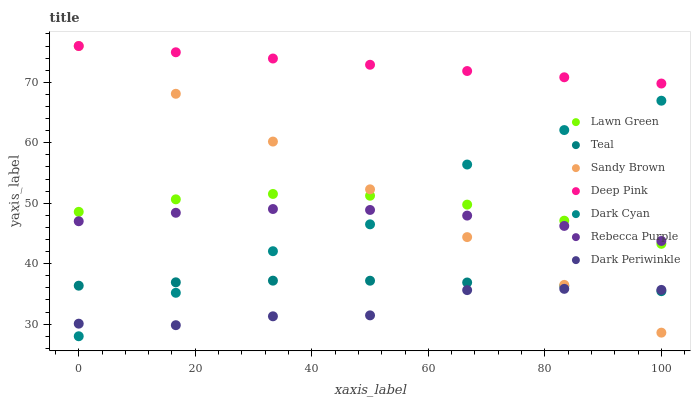Does Dark Periwinkle have the minimum area under the curve?
Answer yes or no. Yes. Does Deep Pink have the maximum area under the curve?
Answer yes or no. Yes. Does Rebecca Purple have the minimum area under the curve?
Answer yes or no. No. Does Rebecca Purple have the maximum area under the curve?
Answer yes or no. No. Is Sandy Brown the smoothest?
Answer yes or no. Yes. Is Dark Cyan the roughest?
Answer yes or no. Yes. Is Deep Pink the smoothest?
Answer yes or no. No. Is Deep Pink the roughest?
Answer yes or no. No. Does Dark Cyan have the lowest value?
Answer yes or no. Yes. Does Rebecca Purple have the lowest value?
Answer yes or no. No. Does Sandy Brown have the highest value?
Answer yes or no. Yes. Does Rebecca Purple have the highest value?
Answer yes or no. No. Is Lawn Green less than Deep Pink?
Answer yes or no. Yes. Is Rebecca Purple greater than Dark Periwinkle?
Answer yes or no. Yes. Does Dark Cyan intersect Sandy Brown?
Answer yes or no. Yes. Is Dark Cyan less than Sandy Brown?
Answer yes or no. No. Is Dark Cyan greater than Sandy Brown?
Answer yes or no. No. Does Lawn Green intersect Deep Pink?
Answer yes or no. No. 